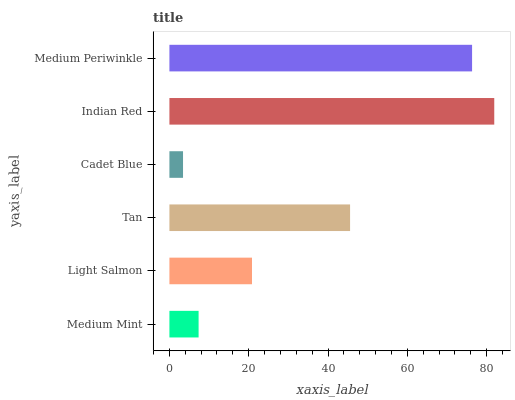Is Cadet Blue the minimum?
Answer yes or no. Yes. Is Indian Red the maximum?
Answer yes or no. Yes. Is Light Salmon the minimum?
Answer yes or no. No. Is Light Salmon the maximum?
Answer yes or no. No. Is Light Salmon greater than Medium Mint?
Answer yes or no. Yes. Is Medium Mint less than Light Salmon?
Answer yes or no. Yes. Is Medium Mint greater than Light Salmon?
Answer yes or no. No. Is Light Salmon less than Medium Mint?
Answer yes or no. No. Is Tan the high median?
Answer yes or no. Yes. Is Light Salmon the low median?
Answer yes or no. Yes. Is Cadet Blue the high median?
Answer yes or no. No. Is Indian Red the low median?
Answer yes or no. No. 